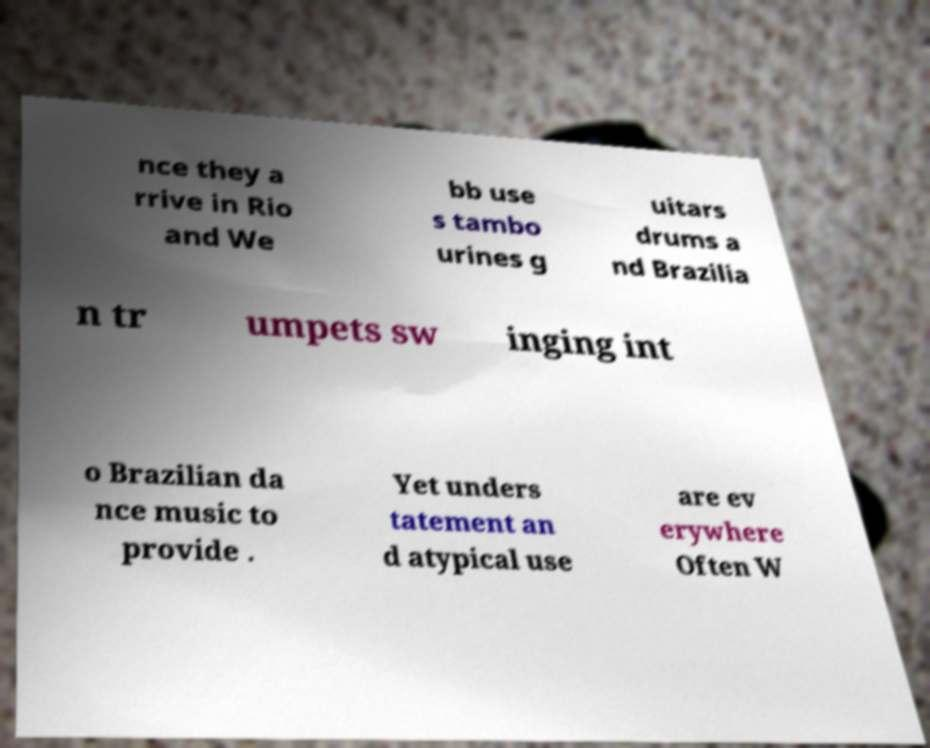Could you assist in decoding the text presented in this image and type it out clearly? nce they a rrive in Rio and We bb use s tambo urines g uitars drums a nd Brazilia n tr umpets sw inging int o Brazilian da nce music to provide . Yet unders tatement an d atypical use are ev erywhere Often W 